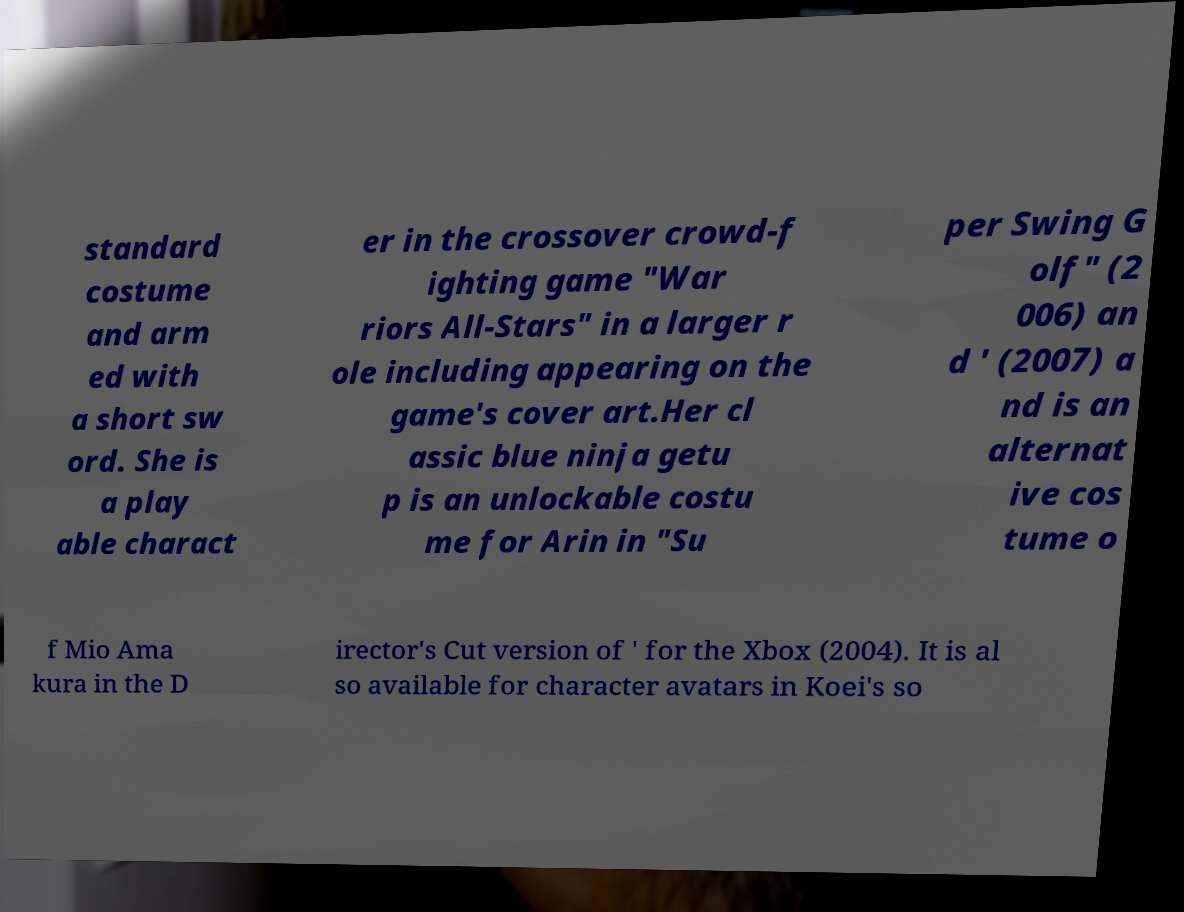Could you assist in decoding the text presented in this image and type it out clearly? standard costume and arm ed with a short sw ord. She is a play able charact er in the crossover crowd-f ighting game "War riors All-Stars" in a larger r ole including appearing on the game's cover art.Her cl assic blue ninja getu p is an unlockable costu me for Arin in "Su per Swing G olf" (2 006) an d ' (2007) a nd is an alternat ive cos tume o f Mio Ama kura in the D irector's Cut version of ' for the Xbox (2004). It is al so available for character avatars in Koei's so 